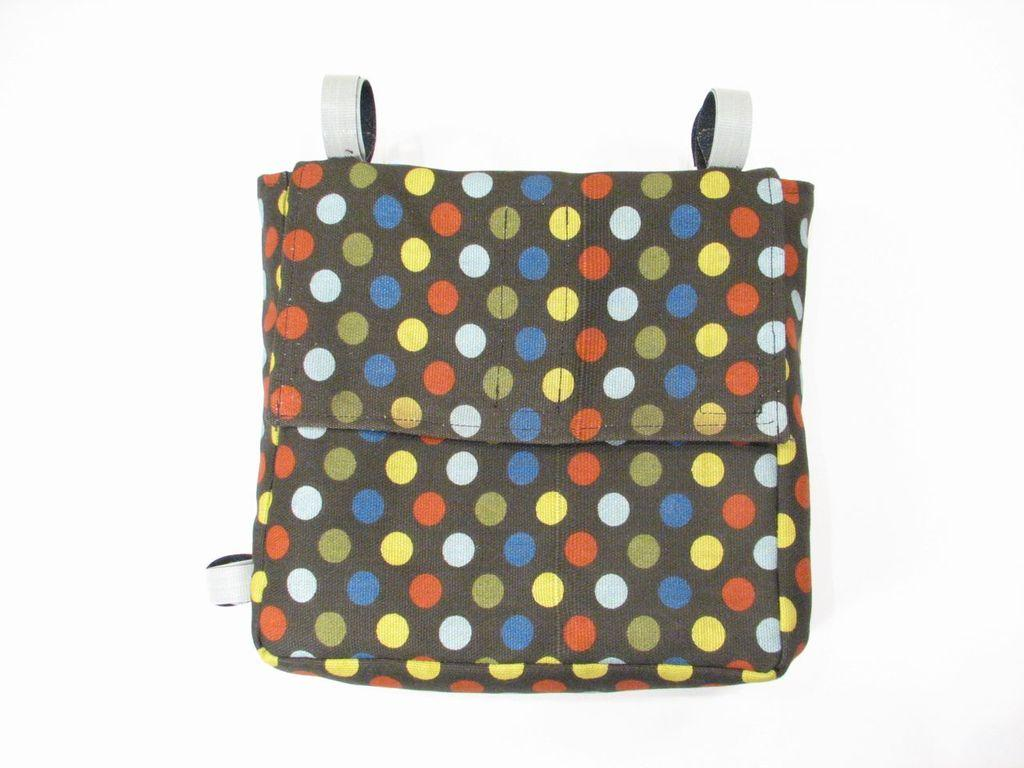What object can be seen in the picture? There is a bag in the picture. What design elements are present on the bag? The bag has colorful dots and white stripes. What type of glass is used to create the dots on the bag? There is no glass present in the image, as the dots are colorful and not made of glass. 